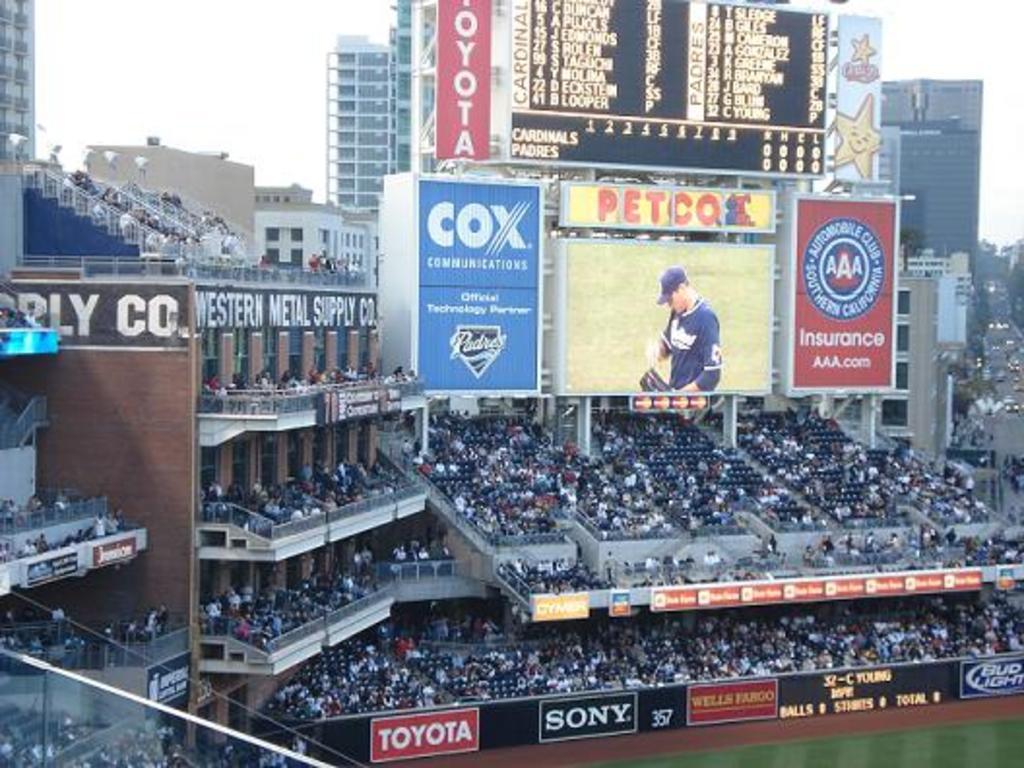What team is listed first on the scoreboard?
Provide a short and direct response. Cardinals. 